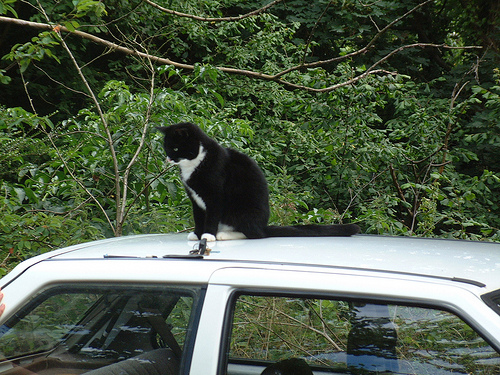<image>
Is there a cat behind the car? No. The cat is not behind the car. From this viewpoint, the cat appears to be positioned elsewhere in the scene. 